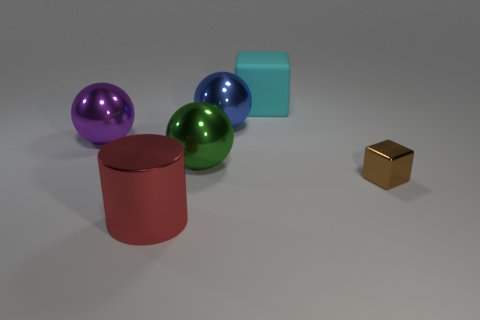There is a ball that is in front of the big metal sphere left of the red shiny object that is on the left side of the blue thing; how big is it?
Offer a terse response. Large. Does the large green metal object have the same shape as the big object that is in front of the large green sphere?
Your answer should be compact. No. What number of blocks are small things or green shiny things?
Provide a succinct answer. 1. Are there any big green shiny things that have the same shape as the purple shiny thing?
Your answer should be compact. Yes. How many other objects are there of the same color as the cylinder?
Ensure brevity in your answer.  0. Is the number of things that are in front of the blue object less than the number of big green blocks?
Keep it short and to the point. No. How many tiny brown rubber things are there?
Ensure brevity in your answer.  0. How many big blue balls are made of the same material as the brown cube?
Your response must be concise. 1. How many things are things behind the big green metallic sphere or small brown cubes?
Ensure brevity in your answer.  4. Are there fewer large metal cylinders that are on the right side of the big blue sphere than green things in front of the purple object?
Provide a short and direct response. Yes. 